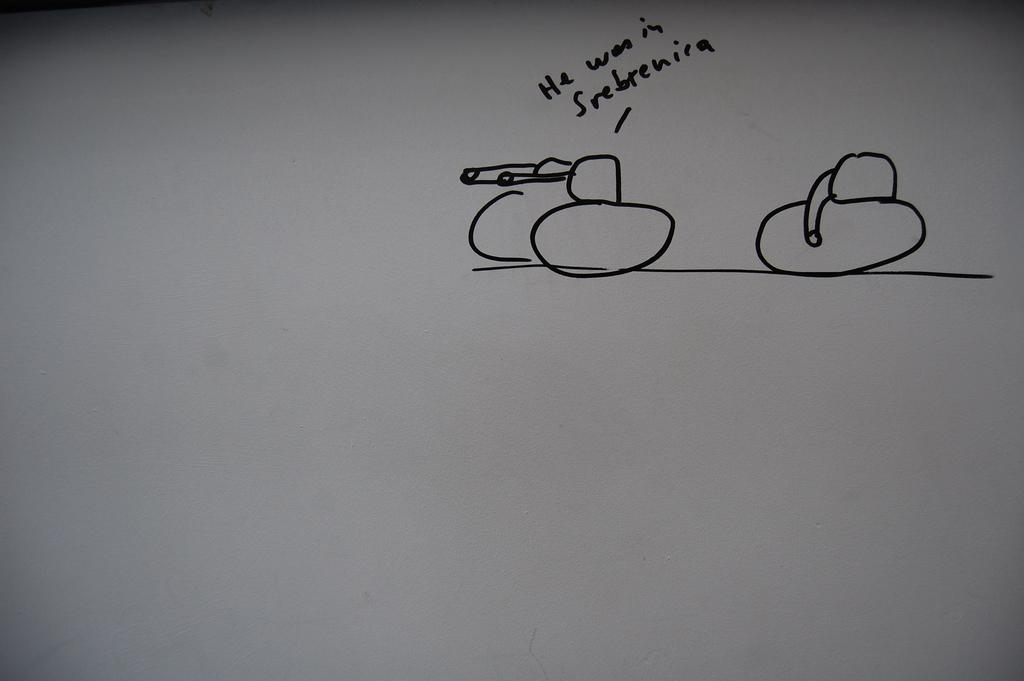What is present on the paper in the image? The paper has a drawing on it. What else can be seen on the paper besides the drawing? There is text written on the paper. Can you describe the snake made of oatmeal in the image? There is no snake or oatmeal present in the image; it only features a paper with a drawing and text. 